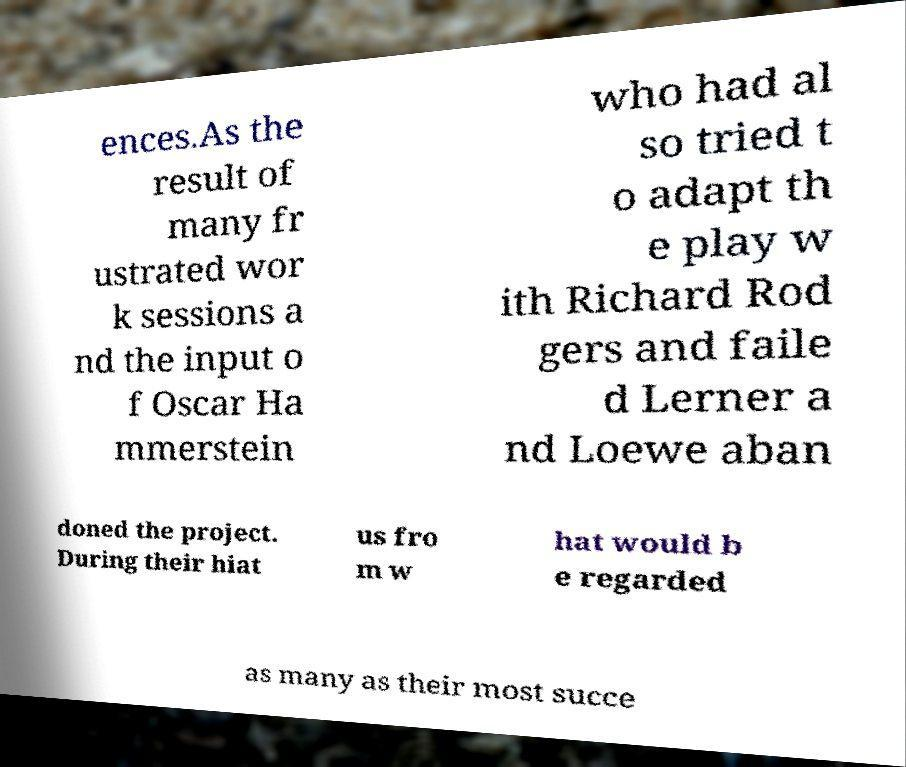Can you read and provide the text displayed in the image?This photo seems to have some interesting text. Can you extract and type it out for me? ences.As the result of many fr ustrated wor k sessions a nd the input o f Oscar Ha mmerstein who had al so tried t o adapt th e play w ith Richard Rod gers and faile d Lerner a nd Loewe aban doned the project. During their hiat us fro m w hat would b e regarded as many as their most succe 